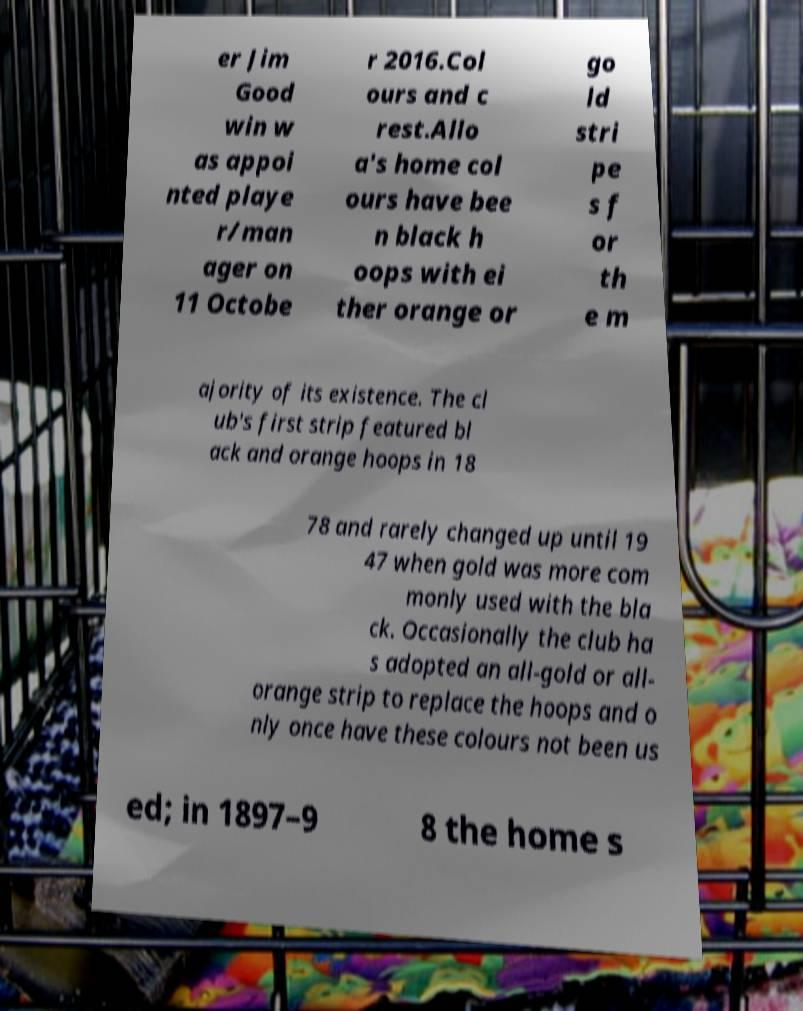Can you read and provide the text displayed in the image?This photo seems to have some interesting text. Can you extract and type it out for me? er Jim Good win w as appoi nted playe r/man ager on 11 Octobe r 2016.Col ours and c rest.Allo a's home col ours have bee n black h oops with ei ther orange or go ld stri pe s f or th e m ajority of its existence. The cl ub's first strip featured bl ack and orange hoops in 18 78 and rarely changed up until 19 47 when gold was more com monly used with the bla ck. Occasionally the club ha s adopted an all-gold or all- orange strip to replace the hoops and o nly once have these colours not been us ed; in 1897–9 8 the home s 